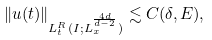Convert formula to latex. <formula><loc_0><loc_0><loc_500><loc_500>\| u ( t ) \| _ { L ^ { R } _ { t } ( I ; L ^ { \frac { 4 d } { d - 2 } } _ { x } ) } \lesssim C ( \delta , E ) ,</formula> 